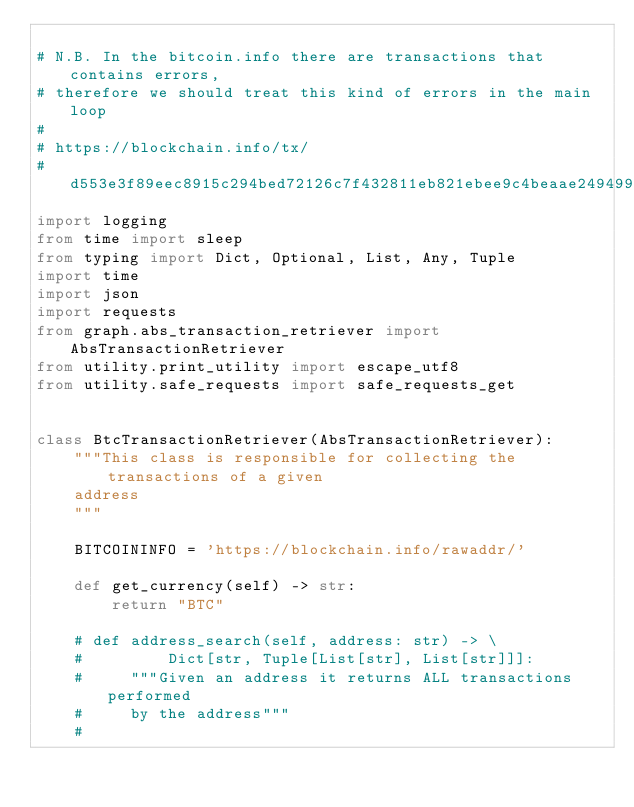<code> <loc_0><loc_0><loc_500><loc_500><_Python_>
# N.B. In the bitcoin.info there are transactions that contains errors,
# therefore we should treat this kind of errors in the main loop
#
# https://blockchain.info/tx/
# d553e3f89eec8915c294bed72126c7f432811eb821ebee9c4beaae249499058d
import logging
from time import sleep
from typing import Dict, Optional, List, Any, Tuple
import time
import json
import requests
from graph.abs_transaction_retriever import AbsTransactionRetriever
from utility.print_utility import escape_utf8
from utility.safe_requests import safe_requests_get


class BtcTransactionRetriever(AbsTransactionRetriever):
    """This class is responsible for collecting the transactions of a given
    address
    """

    BITCOININFO = 'https://blockchain.info/rawaddr/'

    def get_currency(self) -> str:
        return "BTC"

    # def address_search(self, address: str) -> \
    #         Dict[str, Tuple[List[str], List[str]]]:
    #     """Given an address it returns ALL transactions performed
    #     by the address"""
    #</code> 